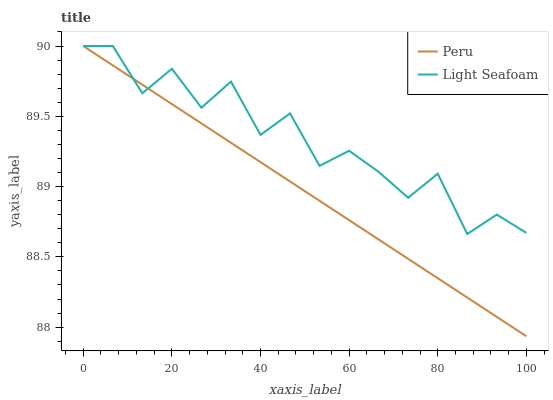Does Peru have the minimum area under the curve?
Answer yes or no. Yes. Does Light Seafoam have the maximum area under the curve?
Answer yes or no. Yes. Does Peru have the maximum area under the curve?
Answer yes or no. No. Is Peru the smoothest?
Answer yes or no. Yes. Is Light Seafoam the roughest?
Answer yes or no. Yes. Is Peru the roughest?
Answer yes or no. No. Does Peru have the lowest value?
Answer yes or no. Yes. Does Peru have the highest value?
Answer yes or no. Yes. Does Peru intersect Light Seafoam?
Answer yes or no. Yes. Is Peru less than Light Seafoam?
Answer yes or no. No. Is Peru greater than Light Seafoam?
Answer yes or no. No. 